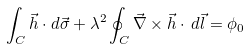<formula> <loc_0><loc_0><loc_500><loc_500>\int _ { C } \vec { h } \cdot d \vec { \sigma } + \lambda ^ { 2 } \oint _ { C } \vec { \nabla } \times \vec { h } \cdot \, d \vec { l } = \phi _ { 0 }</formula> 